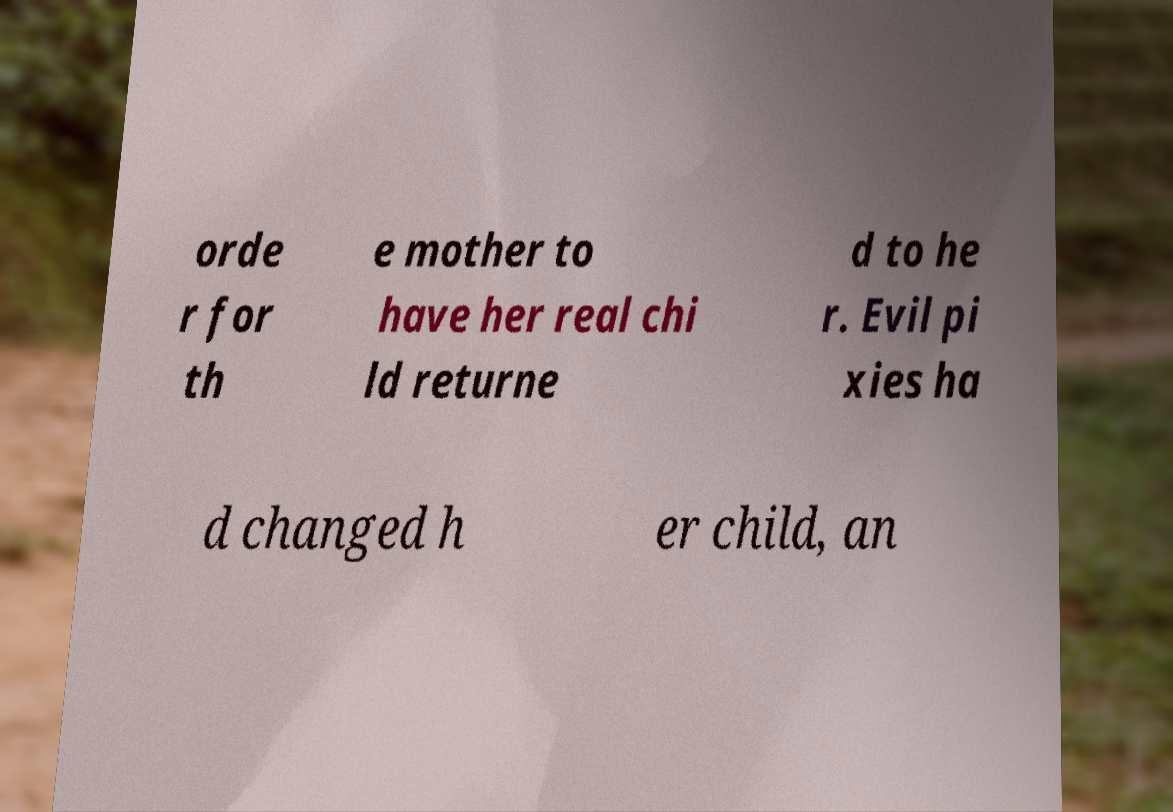Please read and relay the text visible in this image. What does it say? orde r for th e mother to have her real chi ld returne d to he r. Evil pi xies ha d changed h er child, an 